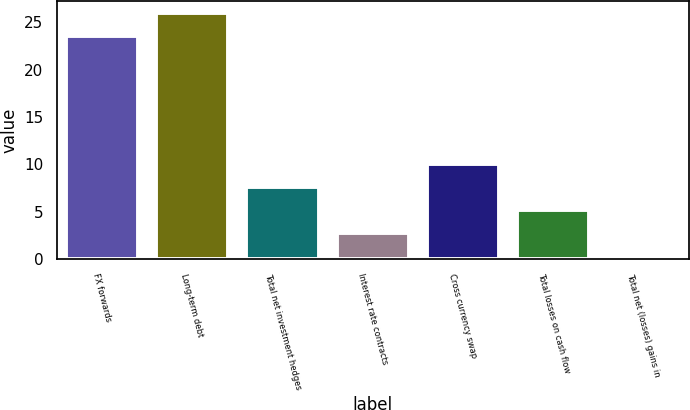Convert chart. <chart><loc_0><loc_0><loc_500><loc_500><bar_chart><fcel>FX forwards<fcel>Long-term debt<fcel>Total net investment hedges<fcel>Interest rate contracts<fcel>Cross currency swap<fcel>Total losses on cash flow<fcel>Total net (losses) gains in<nl><fcel>23.5<fcel>25.94<fcel>7.62<fcel>2.74<fcel>10.06<fcel>5.18<fcel>0.3<nl></chart> 